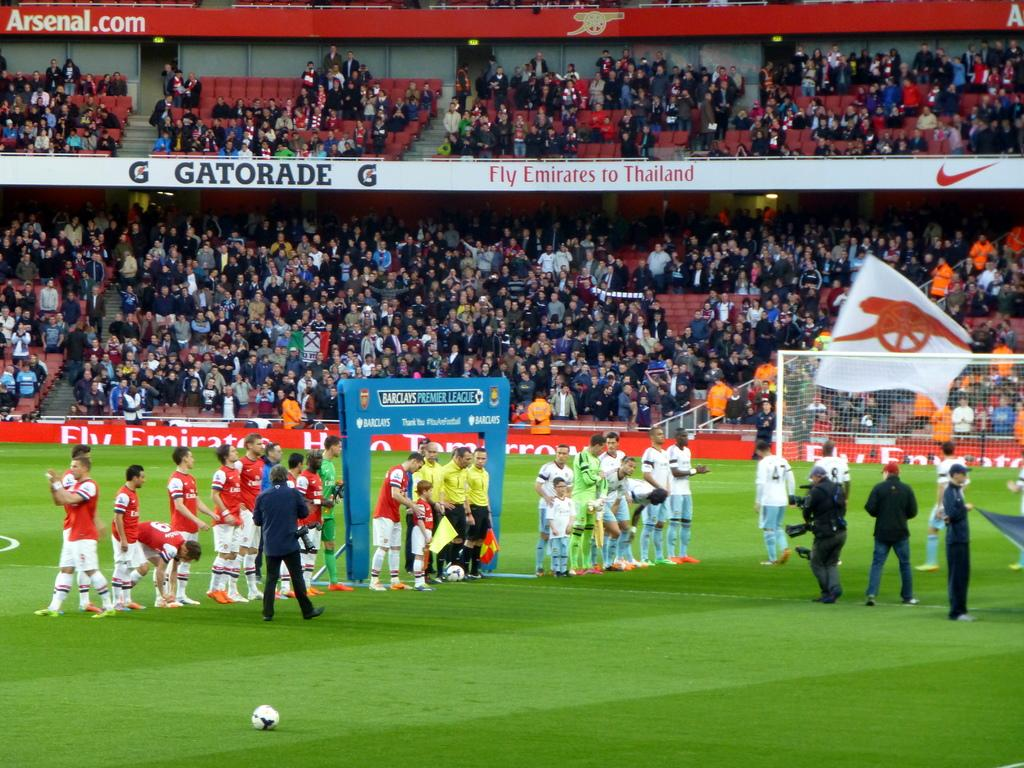Provide a one-sentence caption for the provided image. Soccer players on the field near a Barclays Premier League Banner. 